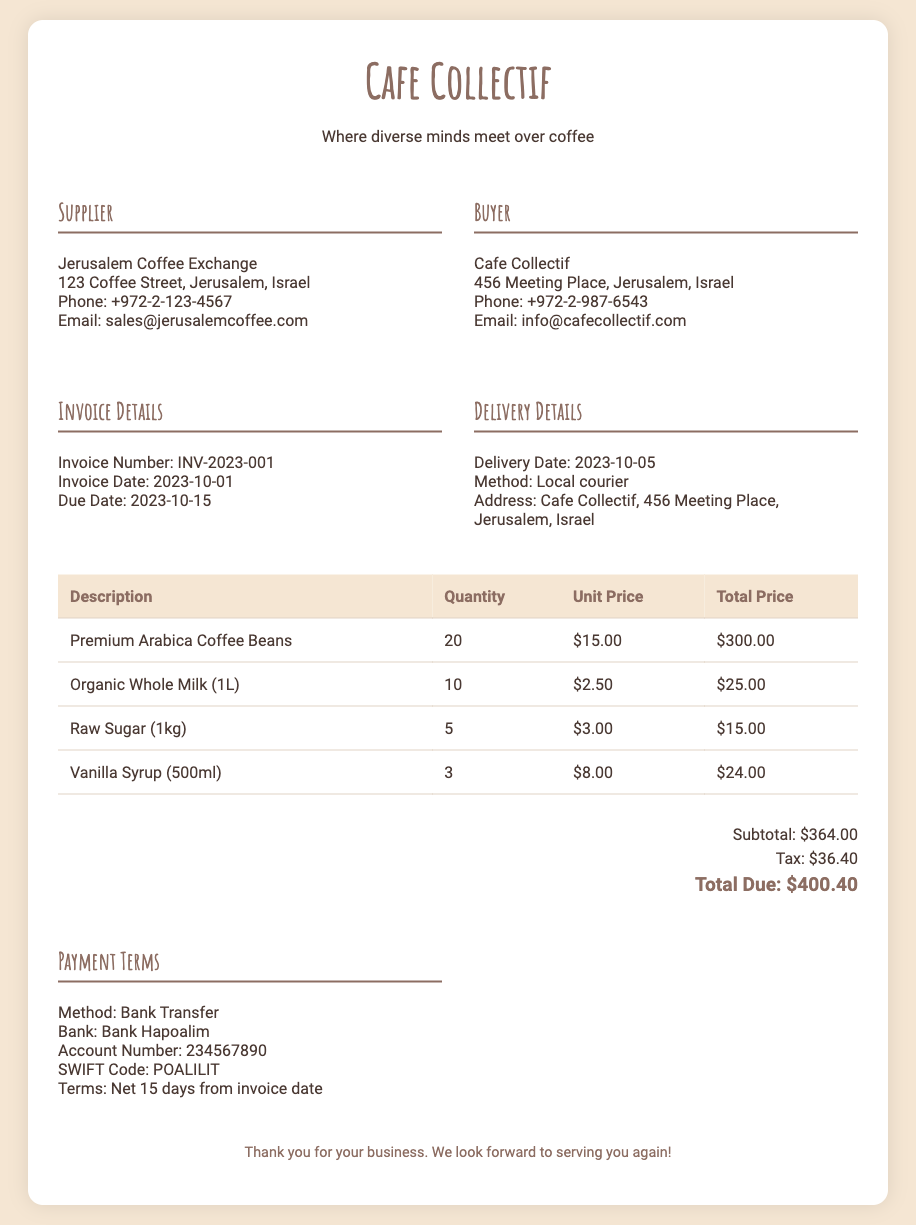What is the name of the supplier? The supplier's name is prominently stated in the document.
Answer: Jerusalem Coffee Exchange What is the total due amount? The total due is calculated after adding the subtotal and tax provided in the document.
Answer: $400.40 What is the invoice number? The invoice number is a unique identifier for the transaction, found in the invoice details section.
Answer: INV-2023-001 What is the delivery date? The delivery date specifies when the goods are expected to arrive, which is stated in the delivery details section.
Answer: 2023-10-05 How many kilograms of raw sugar were ordered? The quantity of raw sugar listed in the invoice table indicates the amount ordered.
Answer: 5 What are the payment terms? The payment terms detail how and when payment should be made, specifically referencing the bank and terms.
Answer: Net 15 days from invoice date What method will be used for delivery? The delivery method is specified within the delivery details section of the document.
Answer: Local courier What is the account number for payment? The account number is required for the bank transfer, provided in the payment terms section.
Answer: 234567890 How many liters of organic whole milk were ordered? The quantity of organic whole milk is listed in the invoice table under the ingredients section.
Answer: 10 